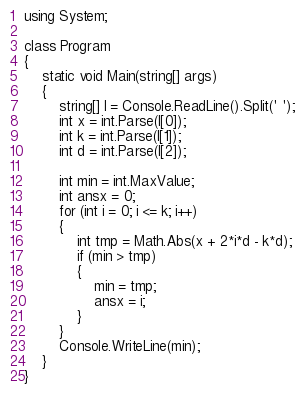<code> <loc_0><loc_0><loc_500><loc_500><_C#_>using System;

class Program
{
    static void Main(string[] args)
    {
        string[] I = Console.ReadLine().Split(' ');
        int x = int.Parse(I[0]);
        int k = int.Parse(I[1]);
        int d = int.Parse(I[2]);

        int min = int.MaxValue;
        int ansx = 0;
        for (int i = 0; i <= k; i++)
        {
            int tmp = Math.Abs(x + 2*i*d - k*d);
            if (min > tmp)
            {
                min = tmp;
                ansx = i;
            }
        }
        Console.WriteLine(min);
    }
}</code> 